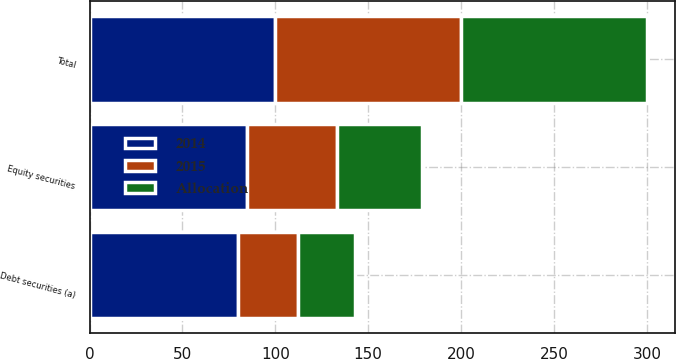<chart> <loc_0><loc_0><loc_500><loc_500><stacked_bar_chart><ecel><fcel>Debt securities (a)<fcel>Equity securities<fcel>Total<nl><fcel>2014<fcel>80<fcel>85<fcel>100<nl><fcel>2015<fcel>32<fcel>48<fcel>100<nl><fcel>Allocation<fcel>31<fcel>46<fcel>100<nl></chart> 